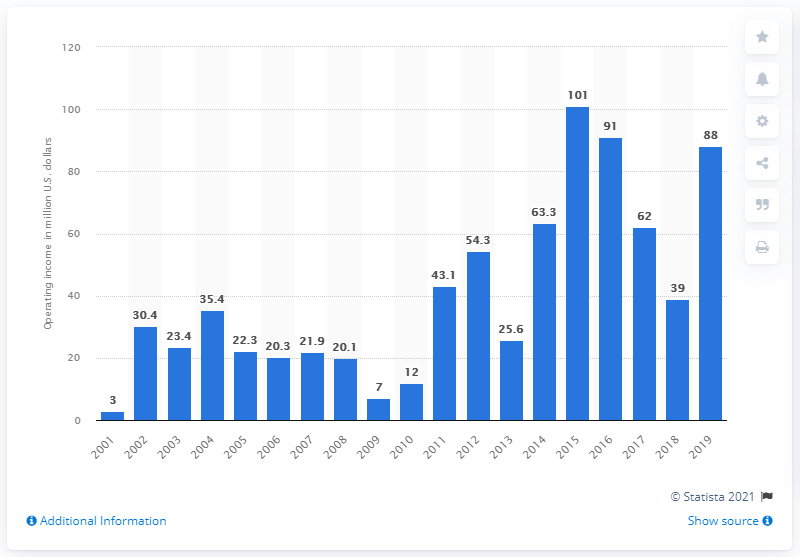Draw attention to some important aspects in this diagram. The operating income of the Green Bay Packers in the 2019 season was 88. 